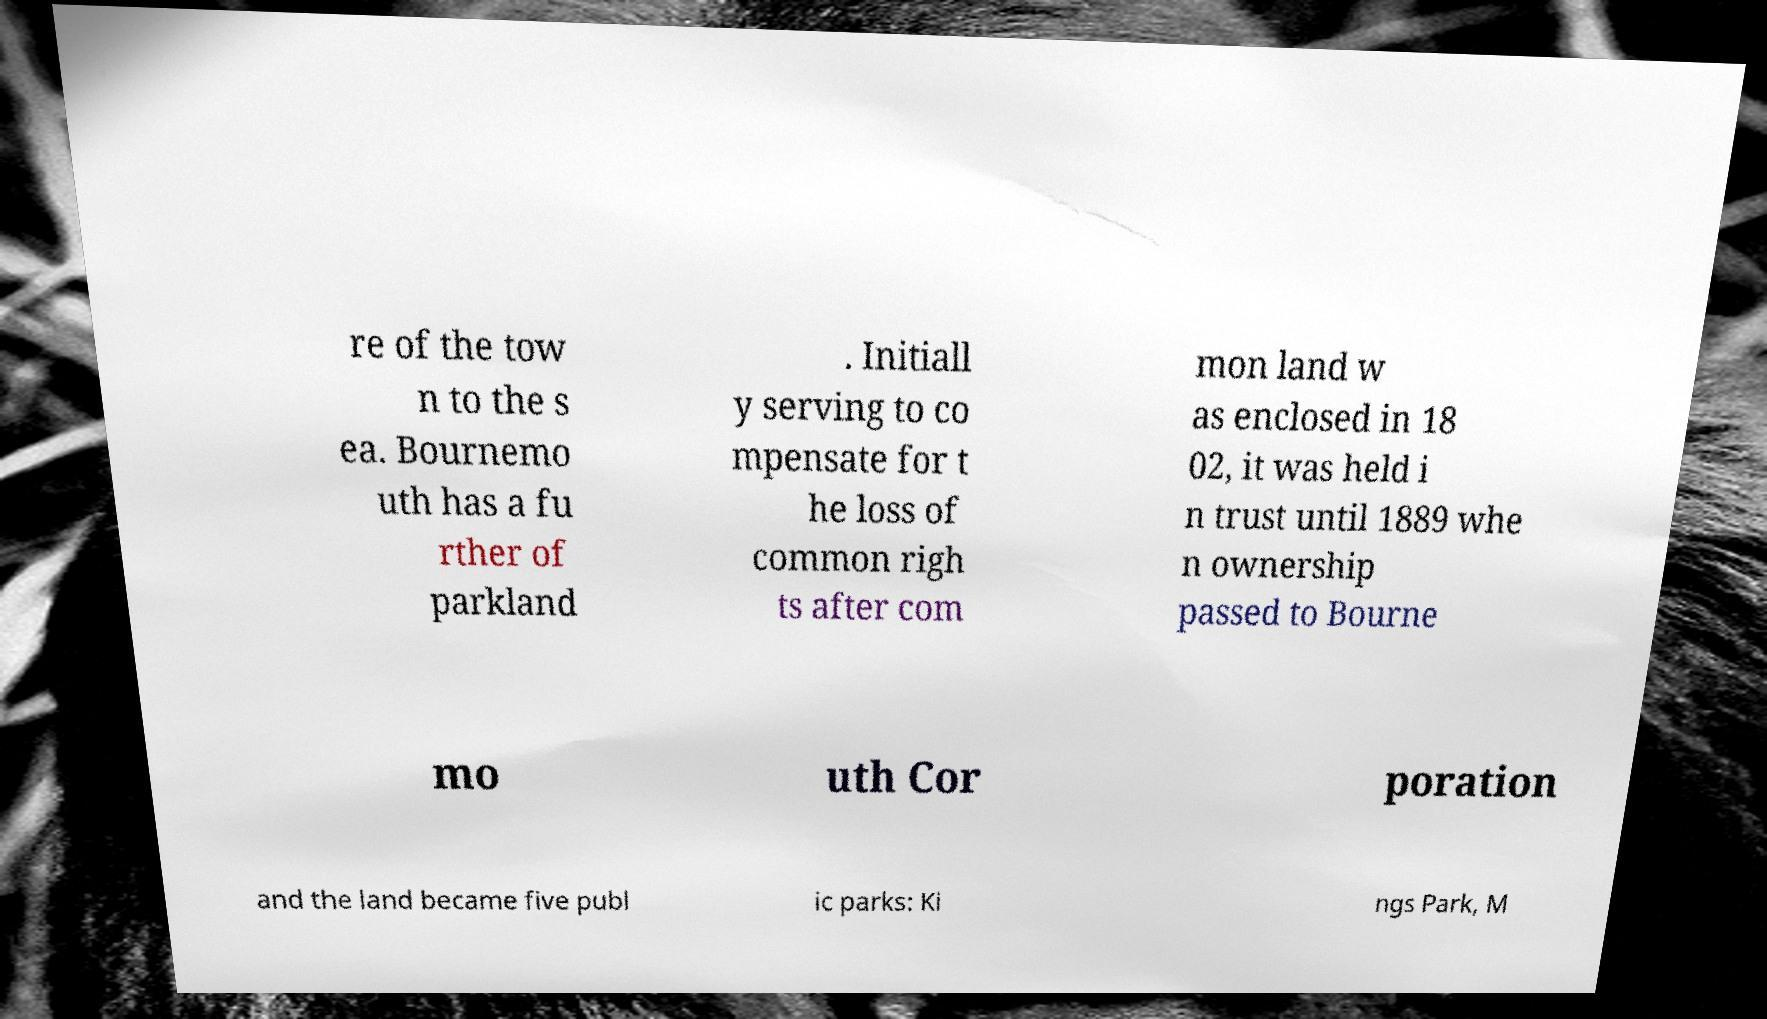Can you accurately transcribe the text from the provided image for me? re of the tow n to the s ea. Bournemo uth has a fu rther of parkland . Initiall y serving to co mpensate for t he loss of common righ ts after com mon land w as enclosed in 18 02, it was held i n trust until 1889 whe n ownership passed to Bourne mo uth Cor poration and the land became five publ ic parks: Ki ngs Park, M 